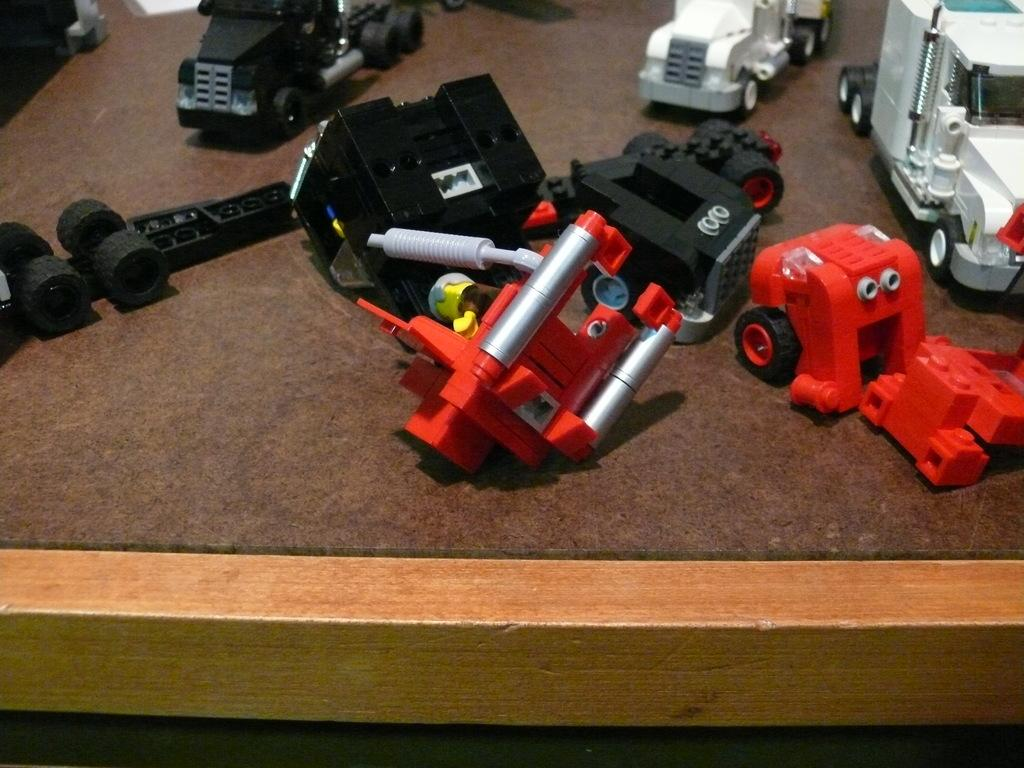What type of objects can be seen in the image? There are toys in the image. Can you describe the specific types of toys? Some of the toys are trucks. Where are the toys located? The toys are present on a table. What type of tree is depicted in the image? There is no tree present in the image; it features toys, some of which are trucks, on a table. What type of writing can be seen on the trucks in the image? There is no writing present on the trucks in the image; it only mentions that some of the toys are trucks. 